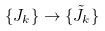Convert formula to latex. <formula><loc_0><loc_0><loc_500><loc_500>\{ J _ { k } \} \rightarrow \{ \tilde { J } _ { k } \}</formula> 